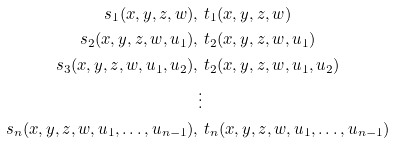Convert formula to latex. <formula><loc_0><loc_0><loc_500><loc_500>s _ { 1 } ( x , y , z , w ) , & \ t _ { 1 } ( x , y , z , w ) \\ s _ { 2 } ( x , y , z , w , u _ { 1 } ) , & \ t _ { 2 } ( x , y , z , w , u _ { 1 } ) \\ s _ { 3 } ( x , y , z , w , u _ { 1 } , u _ { 2 } ) , & \ t _ { 2 } ( x , y , z , w , u _ { 1 } , u _ { 2 } ) \\ & \vdots \\ s _ { n } ( x , y , z , w , u _ { 1 } , \dots , u _ { n - 1 } ) , & \ t _ { n } ( x , y , z , w , u _ { 1 } , \dots , u _ { n - 1 } )</formula> 